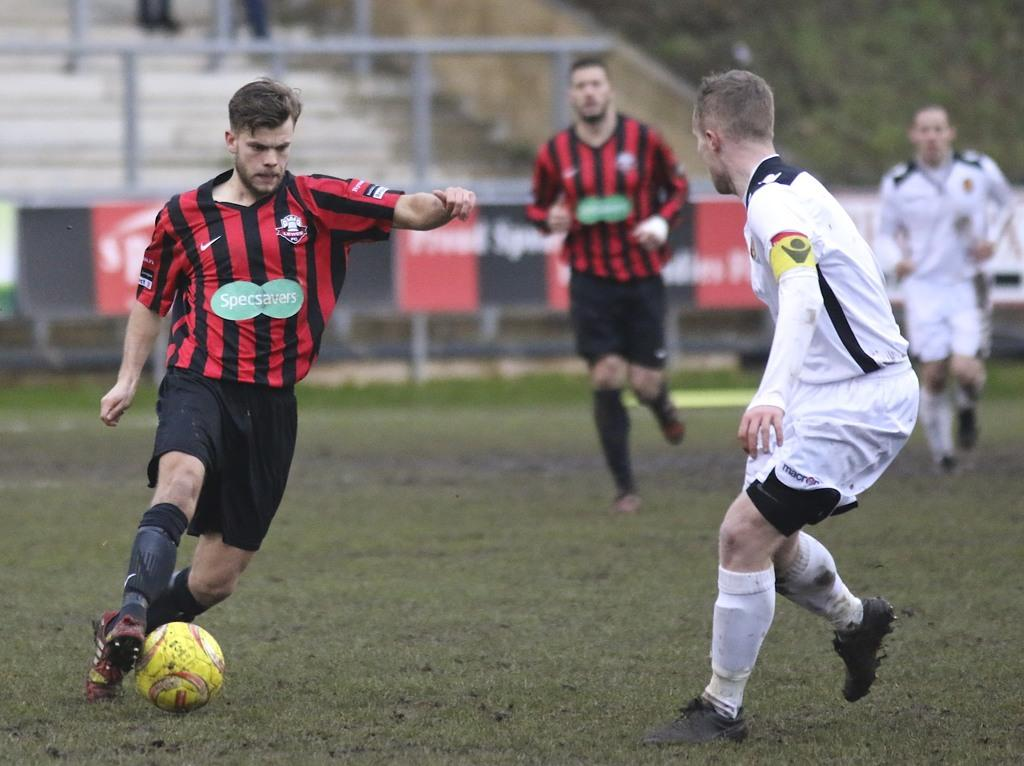How many people are present in the image? There are four people in the image. What activity are the people engaged in? The people are playing football. Where is the image set? The football ground is the setting for the image. What type of plantation can be seen in the background of the image? There is no plantation present in the image; it is set on a football ground. 